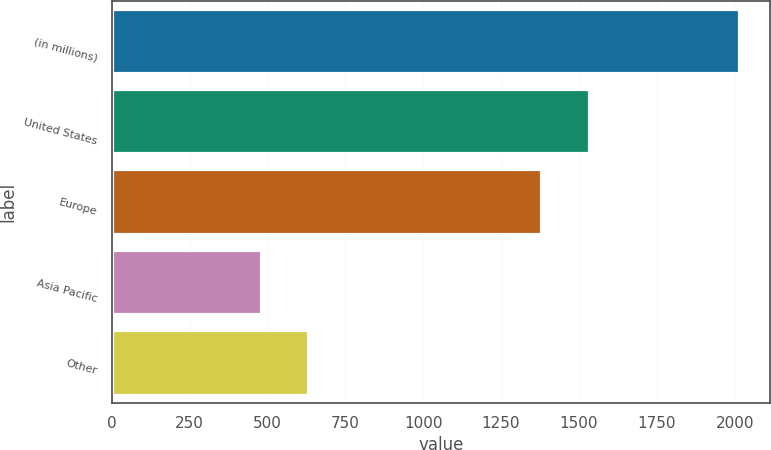<chart> <loc_0><loc_0><loc_500><loc_500><bar_chart><fcel>(in millions)<fcel>United States<fcel>Europe<fcel>Asia Pacific<fcel>Other<nl><fcel>2014<fcel>1532.6<fcel>1379<fcel>478<fcel>631.6<nl></chart> 